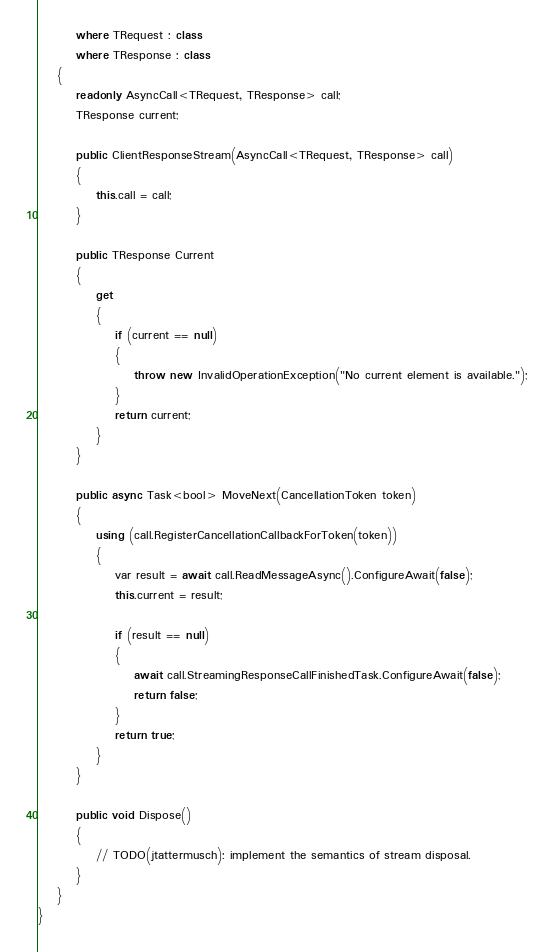Convert code to text. <code><loc_0><loc_0><loc_500><loc_500><_C#_>        where TRequest : class
        where TResponse : class
    {
        readonly AsyncCall<TRequest, TResponse> call;
        TResponse current;

        public ClientResponseStream(AsyncCall<TRequest, TResponse> call)
        {
            this.call = call;
        }

        public TResponse Current
        {
            get
            {
                if (current == null)
                {
                    throw new InvalidOperationException("No current element is available.");
                }
                return current;
            }
        }

        public async Task<bool> MoveNext(CancellationToken token)
        {
            using (call.RegisterCancellationCallbackForToken(token))
            {
                var result = await call.ReadMessageAsync().ConfigureAwait(false);
                this.current = result;

                if (result == null)
                {
                    await call.StreamingResponseCallFinishedTask.ConfigureAwait(false);
                    return false;
                }
                return true;
            }
        }

        public void Dispose()
        {
            // TODO(jtattermusch): implement the semantics of stream disposal.
        }
    }
}
</code> 